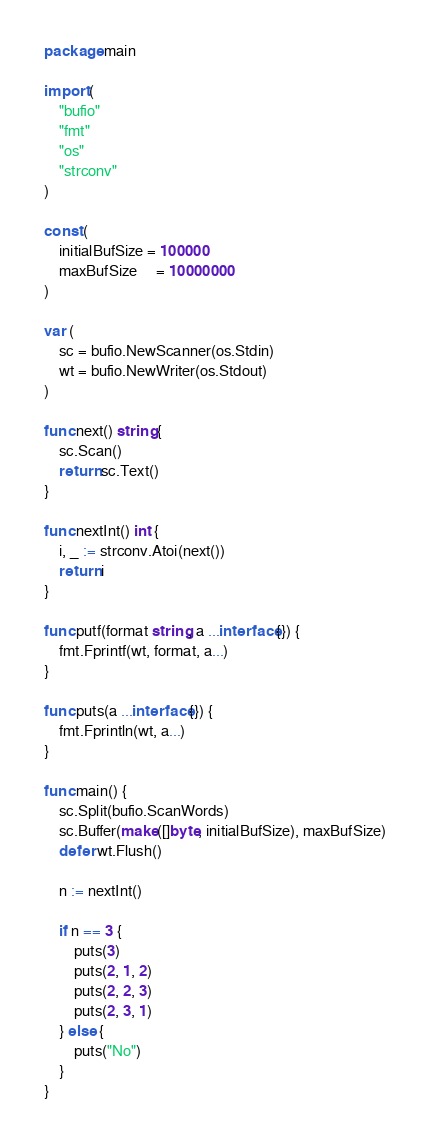Convert code to text. <code><loc_0><loc_0><loc_500><loc_500><_Go_>package main

import (
	"bufio"
	"fmt"
	"os"
	"strconv"
)

const (
	initialBufSize = 100000
	maxBufSize     = 10000000
)

var (
	sc = bufio.NewScanner(os.Stdin)
	wt = bufio.NewWriter(os.Stdout)
)

func next() string {
	sc.Scan()
	return sc.Text()
}

func nextInt() int {
	i, _ := strconv.Atoi(next())
	return i
}

func putf(format string, a ...interface{}) {
	fmt.Fprintf(wt, format, a...)
}

func puts(a ...interface{}) {
	fmt.Fprintln(wt, a...)
}

func main() {
	sc.Split(bufio.ScanWords)
	sc.Buffer(make([]byte, initialBufSize), maxBufSize)
	defer wt.Flush()

	n := nextInt()

	if n == 3 {
		puts(3)
		puts(2, 1, 2)
		puts(2, 2, 3)
		puts(2, 3, 1)
	} else {
		puts("No")
	}
}
</code> 